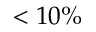<formula> <loc_0><loc_0><loc_500><loc_500>< 1 0 \%</formula> 